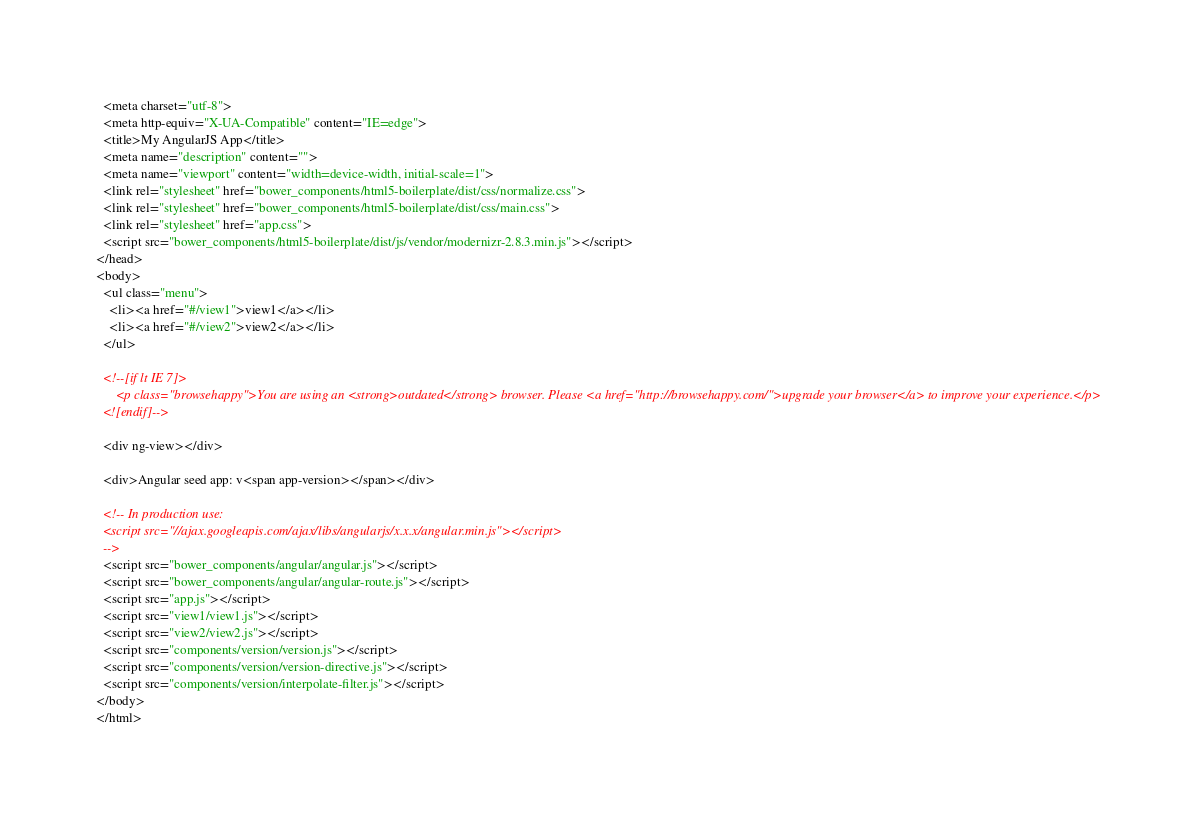Convert code to text. <code><loc_0><loc_0><loc_500><loc_500><_HTML_>  <meta charset="utf-8">
  <meta http-equiv="X-UA-Compatible" content="IE=edge">
  <title>My AngularJS App</title>
  <meta name="description" content="">
  <meta name="viewport" content="width=device-width, initial-scale=1">
  <link rel="stylesheet" href="bower_components/html5-boilerplate/dist/css/normalize.css">
  <link rel="stylesheet" href="bower_components/html5-boilerplate/dist/css/main.css">
  <link rel="stylesheet" href="app.css">
  <script src="bower_components/html5-boilerplate/dist/js/vendor/modernizr-2.8.3.min.js"></script>
</head>
<body>
  <ul class="menu">
    <li><a href="#/view1">view1</a></li>
    <li><a href="#/view2">view2</a></li>
  </ul>

  <!--[if lt IE 7]>
      <p class="browsehappy">You are using an <strong>outdated</strong> browser. Please <a href="http://browsehappy.com/">upgrade your browser</a> to improve your experience.</p>
  <![endif]-->

  <div ng-view></div>

  <div>Angular seed app: v<span app-version></span></div>

  <!-- In production use:
  <script src="//ajax.googleapis.com/ajax/libs/angularjs/x.x.x/angular.min.js"></script>
  -->
  <script src="bower_components/angular/angular.js"></script>
  <script src="bower_components/angular/angular-route.js"></script>
  <script src="app.js"></script>
  <script src="view1/view1.js"></script>
  <script src="view2/view2.js"></script>
  <script src="components/version/version.js"></script>
  <script src="components/version/version-directive.js"></script>
  <script src="components/version/interpolate-filter.js"></script>
</body>
</html>
</code> 